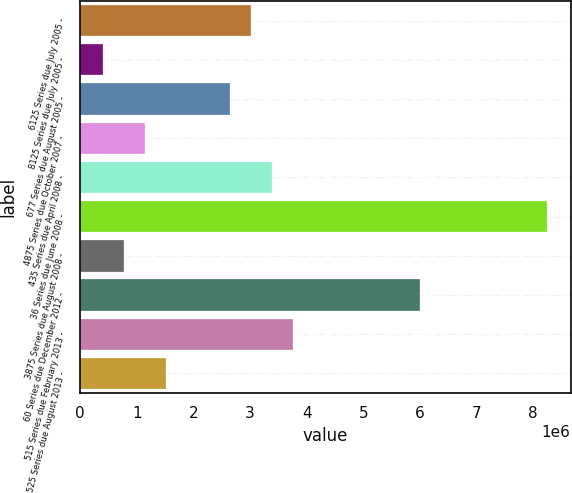Convert chart. <chart><loc_0><loc_0><loc_500><loc_500><bar_chart><fcel>6125 Series due July 2005 -<fcel>8125 Series due July 2005 -<fcel>677 Series due August 2005 -<fcel>4875 Series due October 2007 -<fcel>435 Series due April 2008 -<fcel>36 Series due June 2008 -<fcel>3875 Series due August 2008 -<fcel>60 Series due December 2012 -<fcel>515 Series due February 2013 -<fcel>525 Series due August 2013 -<nl><fcel>3.0154e+06<fcel>398800<fcel>2.6416e+06<fcel>1.1464e+06<fcel>3.3892e+06<fcel>8.2486e+06<fcel>772600<fcel>6.0058e+06<fcel>3.763e+06<fcel>1.5202e+06<nl></chart> 